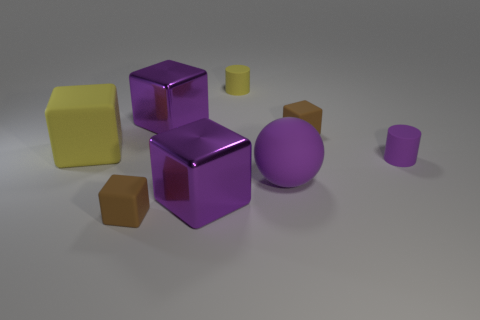Subtract all shiny blocks. How many blocks are left? 3 Add 1 small purple things. How many objects exist? 9 Subtract all purple blocks. How many blocks are left? 3 Subtract all cylinders. How many objects are left? 6 Subtract 1 cylinders. How many cylinders are left? 1 Subtract all yellow blocks. How many cyan cylinders are left? 0 Subtract all big gray matte blocks. Subtract all tiny cylinders. How many objects are left? 6 Add 4 yellow objects. How many yellow objects are left? 6 Add 7 small purple cylinders. How many small purple cylinders exist? 8 Subtract 0 yellow spheres. How many objects are left? 8 